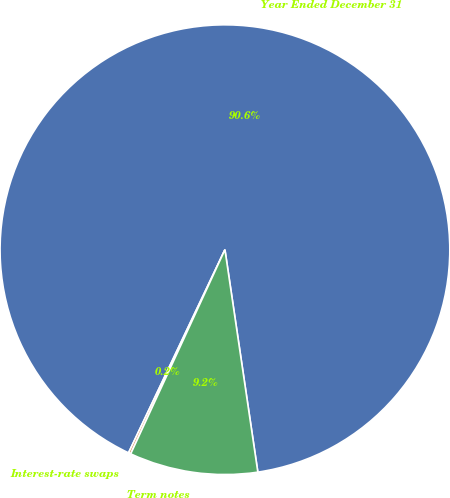<chart> <loc_0><loc_0><loc_500><loc_500><pie_chart><fcel>Year Ended December 31<fcel>Interest-rate swaps<fcel>Term notes<nl><fcel>90.61%<fcel>0.17%<fcel>9.22%<nl></chart> 